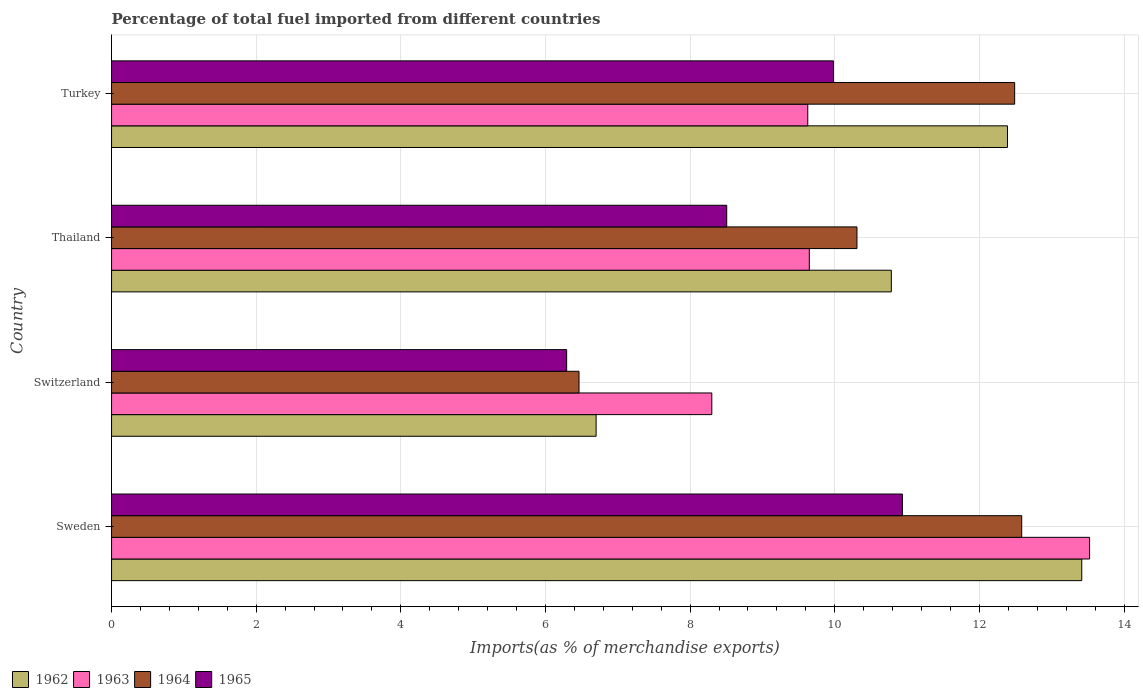How many different coloured bars are there?
Keep it short and to the point. 4. Are the number of bars on each tick of the Y-axis equal?
Provide a short and direct response. Yes. What is the percentage of imports to different countries in 1963 in Thailand?
Provide a succinct answer. 9.65. Across all countries, what is the maximum percentage of imports to different countries in 1965?
Provide a short and direct response. 10.93. Across all countries, what is the minimum percentage of imports to different countries in 1963?
Give a very brief answer. 8.3. In which country was the percentage of imports to different countries in 1965 minimum?
Keep it short and to the point. Switzerland. What is the total percentage of imports to different countries in 1964 in the graph?
Provide a short and direct response. 41.84. What is the difference between the percentage of imports to different countries in 1964 in Sweden and that in Switzerland?
Keep it short and to the point. 6.12. What is the difference between the percentage of imports to different countries in 1965 in Switzerland and the percentage of imports to different countries in 1962 in Sweden?
Make the answer very short. -7.12. What is the average percentage of imports to different countries in 1962 per country?
Ensure brevity in your answer.  10.82. What is the difference between the percentage of imports to different countries in 1962 and percentage of imports to different countries in 1964 in Turkey?
Provide a succinct answer. -0.1. In how many countries, is the percentage of imports to different countries in 1963 greater than 8.4 %?
Offer a terse response. 3. What is the ratio of the percentage of imports to different countries in 1965 in Thailand to that in Turkey?
Your response must be concise. 0.85. Is the difference between the percentage of imports to different countries in 1962 in Thailand and Turkey greater than the difference between the percentage of imports to different countries in 1964 in Thailand and Turkey?
Provide a short and direct response. Yes. What is the difference between the highest and the second highest percentage of imports to different countries in 1965?
Give a very brief answer. 0.95. What is the difference between the highest and the lowest percentage of imports to different countries in 1965?
Ensure brevity in your answer.  4.64. In how many countries, is the percentage of imports to different countries in 1962 greater than the average percentage of imports to different countries in 1962 taken over all countries?
Your response must be concise. 2. What does the 1st bar from the top in Switzerland represents?
Make the answer very short. 1965. How many bars are there?
Your answer should be very brief. 16. Are all the bars in the graph horizontal?
Provide a succinct answer. Yes. Does the graph contain grids?
Make the answer very short. Yes. How are the legend labels stacked?
Give a very brief answer. Horizontal. What is the title of the graph?
Your answer should be compact. Percentage of total fuel imported from different countries. What is the label or title of the X-axis?
Make the answer very short. Imports(as % of merchandise exports). What is the Imports(as % of merchandise exports) of 1962 in Sweden?
Make the answer very short. 13.42. What is the Imports(as % of merchandise exports) in 1963 in Sweden?
Your answer should be very brief. 13.52. What is the Imports(as % of merchandise exports) in 1964 in Sweden?
Offer a terse response. 12.58. What is the Imports(as % of merchandise exports) of 1965 in Sweden?
Your answer should be very brief. 10.93. What is the Imports(as % of merchandise exports) in 1962 in Switzerland?
Provide a short and direct response. 6.7. What is the Imports(as % of merchandise exports) of 1963 in Switzerland?
Your answer should be compact. 8.3. What is the Imports(as % of merchandise exports) in 1964 in Switzerland?
Keep it short and to the point. 6.46. What is the Imports(as % of merchandise exports) in 1965 in Switzerland?
Keep it short and to the point. 6.29. What is the Imports(as % of merchandise exports) in 1962 in Thailand?
Provide a succinct answer. 10.78. What is the Imports(as % of merchandise exports) of 1963 in Thailand?
Your answer should be compact. 9.65. What is the Imports(as % of merchandise exports) of 1964 in Thailand?
Your response must be concise. 10.31. What is the Imports(as % of merchandise exports) of 1965 in Thailand?
Your answer should be very brief. 8.51. What is the Imports(as % of merchandise exports) of 1962 in Turkey?
Provide a short and direct response. 12.39. What is the Imports(as % of merchandise exports) of 1963 in Turkey?
Make the answer very short. 9.63. What is the Imports(as % of merchandise exports) in 1964 in Turkey?
Keep it short and to the point. 12.49. What is the Imports(as % of merchandise exports) in 1965 in Turkey?
Provide a short and direct response. 9.98. Across all countries, what is the maximum Imports(as % of merchandise exports) in 1962?
Give a very brief answer. 13.42. Across all countries, what is the maximum Imports(as % of merchandise exports) in 1963?
Make the answer very short. 13.52. Across all countries, what is the maximum Imports(as % of merchandise exports) of 1964?
Give a very brief answer. 12.58. Across all countries, what is the maximum Imports(as % of merchandise exports) of 1965?
Give a very brief answer. 10.93. Across all countries, what is the minimum Imports(as % of merchandise exports) in 1962?
Provide a short and direct response. 6.7. Across all countries, what is the minimum Imports(as % of merchandise exports) in 1963?
Offer a terse response. 8.3. Across all countries, what is the minimum Imports(as % of merchandise exports) in 1964?
Provide a short and direct response. 6.46. Across all countries, what is the minimum Imports(as % of merchandise exports) of 1965?
Ensure brevity in your answer.  6.29. What is the total Imports(as % of merchandise exports) in 1962 in the graph?
Offer a terse response. 43.29. What is the total Imports(as % of merchandise exports) of 1963 in the graph?
Ensure brevity in your answer.  41.1. What is the total Imports(as % of merchandise exports) of 1964 in the graph?
Your response must be concise. 41.84. What is the total Imports(as % of merchandise exports) of 1965 in the graph?
Your answer should be compact. 35.72. What is the difference between the Imports(as % of merchandise exports) of 1962 in Sweden and that in Switzerland?
Your response must be concise. 6.72. What is the difference between the Imports(as % of merchandise exports) of 1963 in Sweden and that in Switzerland?
Make the answer very short. 5.22. What is the difference between the Imports(as % of merchandise exports) of 1964 in Sweden and that in Switzerland?
Provide a short and direct response. 6.12. What is the difference between the Imports(as % of merchandise exports) in 1965 in Sweden and that in Switzerland?
Ensure brevity in your answer.  4.64. What is the difference between the Imports(as % of merchandise exports) in 1962 in Sweden and that in Thailand?
Your answer should be compact. 2.63. What is the difference between the Imports(as % of merchandise exports) in 1963 in Sweden and that in Thailand?
Your answer should be very brief. 3.88. What is the difference between the Imports(as % of merchandise exports) of 1964 in Sweden and that in Thailand?
Provide a succinct answer. 2.28. What is the difference between the Imports(as % of merchandise exports) in 1965 in Sweden and that in Thailand?
Provide a succinct answer. 2.43. What is the difference between the Imports(as % of merchandise exports) of 1962 in Sweden and that in Turkey?
Your answer should be compact. 1.03. What is the difference between the Imports(as % of merchandise exports) in 1963 in Sweden and that in Turkey?
Keep it short and to the point. 3.9. What is the difference between the Imports(as % of merchandise exports) in 1964 in Sweden and that in Turkey?
Provide a succinct answer. 0.1. What is the difference between the Imports(as % of merchandise exports) of 1965 in Sweden and that in Turkey?
Give a very brief answer. 0.95. What is the difference between the Imports(as % of merchandise exports) in 1962 in Switzerland and that in Thailand?
Make the answer very short. -4.08. What is the difference between the Imports(as % of merchandise exports) of 1963 in Switzerland and that in Thailand?
Make the answer very short. -1.35. What is the difference between the Imports(as % of merchandise exports) in 1964 in Switzerland and that in Thailand?
Give a very brief answer. -3.84. What is the difference between the Imports(as % of merchandise exports) of 1965 in Switzerland and that in Thailand?
Ensure brevity in your answer.  -2.21. What is the difference between the Imports(as % of merchandise exports) of 1962 in Switzerland and that in Turkey?
Ensure brevity in your answer.  -5.69. What is the difference between the Imports(as % of merchandise exports) in 1963 in Switzerland and that in Turkey?
Your response must be concise. -1.33. What is the difference between the Imports(as % of merchandise exports) in 1964 in Switzerland and that in Turkey?
Your response must be concise. -6.02. What is the difference between the Imports(as % of merchandise exports) in 1965 in Switzerland and that in Turkey?
Offer a terse response. -3.69. What is the difference between the Imports(as % of merchandise exports) of 1962 in Thailand and that in Turkey?
Ensure brevity in your answer.  -1.61. What is the difference between the Imports(as % of merchandise exports) in 1963 in Thailand and that in Turkey?
Your answer should be very brief. 0.02. What is the difference between the Imports(as % of merchandise exports) of 1964 in Thailand and that in Turkey?
Provide a succinct answer. -2.18. What is the difference between the Imports(as % of merchandise exports) in 1965 in Thailand and that in Turkey?
Your response must be concise. -1.48. What is the difference between the Imports(as % of merchandise exports) in 1962 in Sweden and the Imports(as % of merchandise exports) in 1963 in Switzerland?
Provide a short and direct response. 5.12. What is the difference between the Imports(as % of merchandise exports) of 1962 in Sweden and the Imports(as % of merchandise exports) of 1964 in Switzerland?
Make the answer very short. 6.95. What is the difference between the Imports(as % of merchandise exports) of 1962 in Sweden and the Imports(as % of merchandise exports) of 1965 in Switzerland?
Provide a succinct answer. 7.12. What is the difference between the Imports(as % of merchandise exports) of 1963 in Sweden and the Imports(as % of merchandise exports) of 1964 in Switzerland?
Make the answer very short. 7.06. What is the difference between the Imports(as % of merchandise exports) in 1963 in Sweden and the Imports(as % of merchandise exports) in 1965 in Switzerland?
Give a very brief answer. 7.23. What is the difference between the Imports(as % of merchandise exports) in 1964 in Sweden and the Imports(as % of merchandise exports) in 1965 in Switzerland?
Ensure brevity in your answer.  6.29. What is the difference between the Imports(as % of merchandise exports) in 1962 in Sweden and the Imports(as % of merchandise exports) in 1963 in Thailand?
Offer a very short reply. 3.77. What is the difference between the Imports(as % of merchandise exports) in 1962 in Sweden and the Imports(as % of merchandise exports) in 1964 in Thailand?
Ensure brevity in your answer.  3.11. What is the difference between the Imports(as % of merchandise exports) of 1962 in Sweden and the Imports(as % of merchandise exports) of 1965 in Thailand?
Your answer should be compact. 4.91. What is the difference between the Imports(as % of merchandise exports) in 1963 in Sweden and the Imports(as % of merchandise exports) in 1964 in Thailand?
Offer a terse response. 3.22. What is the difference between the Imports(as % of merchandise exports) of 1963 in Sweden and the Imports(as % of merchandise exports) of 1965 in Thailand?
Offer a very short reply. 5.02. What is the difference between the Imports(as % of merchandise exports) in 1964 in Sweden and the Imports(as % of merchandise exports) in 1965 in Thailand?
Offer a very short reply. 4.08. What is the difference between the Imports(as % of merchandise exports) of 1962 in Sweden and the Imports(as % of merchandise exports) of 1963 in Turkey?
Ensure brevity in your answer.  3.79. What is the difference between the Imports(as % of merchandise exports) in 1962 in Sweden and the Imports(as % of merchandise exports) in 1964 in Turkey?
Make the answer very short. 0.93. What is the difference between the Imports(as % of merchandise exports) in 1962 in Sweden and the Imports(as % of merchandise exports) in 1965 in Turkey?
Offer a very short reply. 3.43. What is the difference between the Imports(as % of merchandise exports) in 1963 in Sweden and the Imports(as % of merchandise exports) in 1964 in Turkey?
Your answer should be very brief. 1.04. What is the difference between the Imports(as % of merchandise exports) of 1963 in Sweden and the Imports(as % of merchandise exports) of 1965 in Turkey?
Make the answer very short. 3.54. What is the difference between the Imports(as % of merchandise exports) of 1964 in Sweden and the Imports(as % of merchandise exports) of 1965 in Turkey?
Your response must be concise. 2.6. What is the difference between the Imports(as % of merchandise exports) in 1962 in Switzerland and the Imports(as % of merchandise exports) in 1963 in Thailand?
Make the answer very short. -2.95. What is the difference between the Imports(as % of merchandise exports) of 1962 in Switzerland and the Imports(as % of merchandise exports) of 1964 in Thailand?
Your answer should be compact. -3.61. What is the difference between the Imports(as % of merchandise exports) of 1962 in Switzerland and the Imports(as % of merchandise exports) of 1965 in Thailand?
Your answer should be compact. -1.81. What is the difference between the Imports(as % of merchandise exports) in 1963 in Switzerland and the Imports(as % of merchandise exports) in 1964 in Thailand?
Keep it short and to the point. -2.01. What is the difference between the Imports(as % of merchandise exports) in 1963 in Switzerland and the Imports(as % of merchandise exports) in 1965 in Thailand?
Give a very brief answer. -0.21. What is the difference between the Imports(as % of merchandise exports) of 1964 in Switzerland and the Imports(as % of merchandise exports) of 1965 in Thailand?
Your answer should be very brief. -2.04. What is the difference between the Imports(as % of merchandise exports) in 1962 in Switzerland and the Imports(as % of merchandise exports) in 1963 in Turkey?
Give a very brief answer. -2.93. What is the difference between the Imports(as % of merchandise exports) of 1962 in Switzerland and the Imports(as % of merchandise exports) of 1964 in Turkey?
Make the answer very short. -5.79. What is the difference between the Imports(as % of merchandise exports) in 1962 in Switzerland and the Imports(as % of merchandise exports) in 1965 in Turkey?
Your answer should be compact. -3.28. What is the difference between the Imports(as % of merchandise exports) of 1963 in Switzerland and the Imports(as % of merchandise exports) of 1964 in Turkey?
Offer a very short reply. -4.19. What is the difference between the Imports(as % of merchandise exports) of 1963 in Switzerland and the Imports(as % of merchandise exports) of 1965 in Turkey?
Provide a succinct answer. -1.68. What is the difference between the Imports(as % of merchandise exports) in 1964 in Switzerland and the Imports(as % of merchandise exports) in 1965 in Turkey?
Your response must be concise. -3.52. What is the difference between the Imports(as % of merchandise exports) of 1962 in Thailand and the Imports(as % of merchandise exports) of 1963 in Turkey?
Give a very brief answer. 1.16. What is the difference between the Imports(as % of merchandise exports) of 1962 in Thailand and the Imports(as % of merchandise exports) of 1964 in Turkey?
Ensure brevity in your answer.  -1.71. What is the difference between the Imports(as % of merchandise exports) in 1962 in Thailand and the Imports(as % of merchandise exports) in 1965 in Turkey?
Provide a short and direct response. 0.8. What is the difference between the Imports(as % of merchandise exports) in 1963 in Thailand and the Imports(as % of merchandise exports) in 1964 in Turkey?
Provide a short and direct response. -2.84. What is the difference between the Imports(as % of merchandise exports) in 1963 in Thailand and the Imports(as % of merchandise exports) in 1965 in Turkey?
Your answer should be compact. -0.33. What is the difference between the Imports(as % of merchandise exports) in 1964 in Thailand and the Imports(as % of merchandise exports) in 1965 in Turkey?
Make the answer very short. 0.32. What is the average Imports(as % of merchandise exports) of 1962 per country?
Your response must be concise. 10.82. What is the average Imports(as % of merchandise exports) of 1963 per country?
Your answer should be compact. 10.27. What is the average Imports(as % of merchandise exports) of 1964 per country?
Your answer should be compact. 10.46. What is the average Imports(as % of merchandise exports) in 1965 per country?
Your response must be concise. 8.93. What is the difference between the Imports(as % of merchandise exports) in 1962 and Imports(as % of merchandise exports) in 1963 in Sweden?
Your response must be concise. -0.11. What is the difference between the Imports(as % of merchandise exports) in 1962 and Imports(as % of merchandise exports) in 1964 in Sweden?
Offer a terse response. 0.83. What is the difference between the Imports(as % of merchandise exports) of 1962 and Imports(as % of merchandise exports) of 1965 in Sweden?
Ensure brevity in your answer.  2.48. What is the difference between the Imports(as % of merchandise exports) in 1963 and Imports(as % of merchandise exports) in 1964 in Sweden?
Your response must be concise. 0.94. What is the difference between the Imports(as % of merchandise exports) in 1963 and Imports(as % of merchandise exports) in 1965 in Sweden?
Your answer should be compact. 2.59. What is the difference between the Imports(as % of merchandise exports) in 1964 and Imports(as % of merchandise exports) in 1965 in Sweden?
Your response must be concise. 1.65. What is the difference between the Imports(as % of merchandise exports) in 1962 and Imports(as % of merchandise exports) in 1963 in Switzerland?
Provide a short and direct response. -1.6. What is the difference between the Imports(as % of merchandise exports) in 1962 and Imports(as % of merchandise exports) in 1964 in Switzerland?
Provide a succinct answer. 0.24. What is the difference between the Imports(as % of merchandise exports) in 1962 and Imports(as % of merchandise exports) in 1965 in Switzerland?
Keep it short and to the point. 0.41. What is the difference between the Imports(as % of merchandise exports) in 1963 and Imports(as % of merchandise exports) in 1964 in Switzerland?
Your answer should be compact. 1.84. What is the difference between the Imports(as % of merchandise exports) of 1963 and Imports(as % of merchandise exports) of 1965 in Switzerland?
Provide a short and direct response. 2.01. What is the difference between the Imports(as % of merchandise exports) in 1964 and Imports(as % of merchandise exports) in 1965 in Switzerland?
Give a very brief answer. 0.17. What is the difference between the Imports(as % of merchandise exports) of 1962 and Imports(as % of merchandise exports) of 1963 in Thailand?
Ensure brevity in your answer.  1.13. What is the difference between the Imports(as % of merchandise exports) of 1962 and Imports(as % of merchandise exports) of 1964 in Thailand?
Provide a succinct answer. 0.48. What is the difference between the Imports(as % of merchandise exports) in 1962 and Imports(as % of merchandise exports) in 1965 in Thailand?
Offer a terse response. 2.28. What is the difference between the Imports(as % of merchandise exports) of 1963 and Imports(as % of merchandise exports) of 1964 in Thailand?
Provide a short and direct response. -0.66. What is the difference between the Imports(as % of merchandise exports) of 1963 and Imports(as % of merchandise exports) of 1965 in Thailand?
Give a very brief answer. 1.14. What is the difference between the Imports(as % of merchandise exports) of 1964 and Imports(as % of merchandise exports) of 1965 in Thailand?
Keep it short and to the point. 1.8. What is the difference between the Imports(as % of merchandise exports) in 1962 and Imports(as % of merchandise exports) in 1963 in Turkey?
Offer a terse response. 2.76. What is the difference between the Imports(as % of merchandise exports) of 1962 and Imports(as % of merchandise exports) of 1964 in Turkey?
Provide a succinct answer. -0.1. What is the difference between the Imports(as % of merchandise exports) in 1962 and Imports(as % of merchandise exports) in 1965 in Turkey?
Offer a terse response. 2.41. What is the difference between the Imports(as % of merchandise exports) of 1963 and Imports(as % of merchandise exports) of 1964 in Turkey?
Your answer should be compact. -2.86. What is the difference between the Imports(as % of merchandise exports) of 1963 and Imports(as % of merchandise exports) of 1965 in Turkey?
Provide a succinct answer. -0.36. What is the difference between the Imports(as % of merchandise exports) of 1964 and Imports(as % of merchandise exports) of 1965 in Turkey?
Provide a short and direct response. 2.51. What is the ratio of the Imports(as % of merchandise exports) in 1962 in Sweden to that in Switzerland?
Offer a terse response. 2. What is the ratio of the Imports(as % of merchandise exports) of 1963 in Sweden to that in Switzerland?
Your answer should be very brief. 1.63. What is the ratio of the Imports(as % of merchandise exports) in 1964 in Sweden to that in Switzerland?
Offer a terse response. 1.95. What is the ratio of the Imports(as % of merchandise exports) of 1965 in Sweden to that in Switzerland?
Offer a terse response. 1.74. What is the ratio of the Imports(as % of merchandise exports) of 1962 in Sweden to that in Thailand?
Offer a terse response. 1.24. What is the ratio of the Imports(as % of merchandise exports) in 1963 in Sweden to that in Thailand?
Make the answer very short. 1.4. What is the ratio of the Imports(as % of merchandise exports) of 1964 in Sweden to that in Thailand?
Your response must be concise. 1.22. What is the ratio of the Imports(as % of merchandise exports) in 1965 in Sweden to that in Thailand?
Provide a succinct answer. 1.29. What is the ratio of the Imports(as % of merchandise exports) of 1962 in Sweden to that in Turkey?
Give a very brief answer. 1.08. What is the ratio of the Imports(as % of merchandise exports) of 1963 in Sweden to that in Turkey?
Offer a very short reply. 1.4. What is the ratio of the Imports(as % of merchandise exports) in 1964 in Sweden to that in Turkey?
Your response must be concise. 1.01. What is the ratio of the Imports(as % of merchandise exports) in 1965 in Sweden to that in Turkey?
Keep it short and to the point. 1.1. What is the ratio of the Imports(as % of merchandise exports) of 1962 in Switzerland to that in Thailand?
Your response must be concise. 0.62. What is the ratio of the Imports(as % of merchandise exports) in 1963 in Switzerland to that in Thailand?
Provide a short and direct response. 0.86. What is the ratio of the Imports(as % of merchandise exports) in 1964 in Switzerland to that in Thailand?
Your answer should be compact. 0.63. What is the ratio of the Imports(as % of merchandise exports) in 1965 in Switzerland to that in Thailand?
Offer a very short reply. 0.74. What is the ratio of the Imports(as % of merchandise exports) of 1962 in Switzerland to that in Turkey?
Give a very brief answer. 0.54. What is the ratio of the Imports(as % of merchandise exports) of 1963 in Switzerland to that in Turkey?
Offer a very short reply. 0.86. What is the ratio of the Imports(as % of merchandise exports) in 1964 in Switzerland to that in Turkey?
Make the answer very short. 0.52. What is the ratio of the Imports(as % of merchandise exports) in 1965 in Switzerland to that in Turkey?
Ensure brevity in your answer.  0.63. What is the ratio of the Imports(as % of merchandise exports) in 1962 in Thailand to that in Turkey?
Provide a short and direct response. 0.87. What is the ratio of the Imports(as % of merchandise exports) of 1963 in Thailand to that in Turkey?
Offer a very short reply. 1. What is the ratio of the Imports(as % of merchandise exports) of 1964 in Thailand to that in Turkey?
Keep it short and to the point. 0.83. What is the ratio of the Imports(as % of merchandise exports) in 1965 in Thailand to that in Turkey?
Your answer should be very brief. 0.85. What is the difference between the highest and the second highest Imports(as % of merchandise exports) of 1962?
Ensure brevity in your answer.  1.03. What is the difference between the highest and the second highest Imports(as % of merchandise exports) of 1963?
Offer a terse response. 3.88. What is the difference between the highest and the second highest Imports(as % of merchandise exports) in 1964?
Provide a succinct answer. 0.1. What is the difference between the highest and the second highest Imports(as % of merchandise exports) in 1965?
Give a very brief answer. 0.95. What is the difference between the highest and the lowest Imports(as % of merchandise exports) of 1962?
Make the answer very short. 6.72. What is the difference between the highest and the lowest Imports(as % of merchandise exports) in 1963?
Keep it short and to the point. 5.22. What is the difference between the highest and the lowest Imports(as % of merchandise exports) in 1964?
Give a very brief answer. 6.12. What is the difference between the highest and the lowest Imports(as % of merchandise exports) in 1965?
Your answer should be very brief. 4.64. 